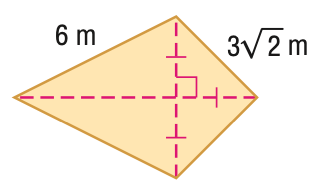Question: Find the perimeter of the figure in feet. Round to the nearest tenth, if necessary.
Choices:
A. 20.5
B. 21
C. 22.4
D. 24
Answer with the letter. Answer: A Question: Find the area of the figure in feet. Round to the nearest tenth, if necessary.
Choices:
A. 24.6
B. 25.5
C. 31.2
D. 36
Answer with the letter. Answer: C 